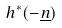<formula> <loc_0><loc_0><loc_500><loc_500>h ^ { * } ( - \underline { n } )</formula> 